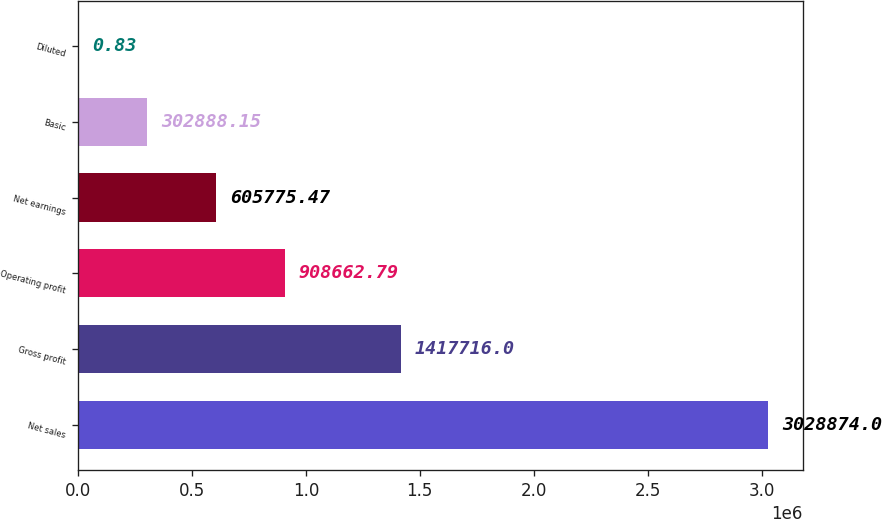Convert chart to OTSL. <chart><loc_0><loc_0><loc_500><loc_500><bar_chart><fcel>Net sales<fcel>Gross profit<fcel>Operating profit<fcel>Net earnings<fcel>Basic<fcel>Diluted<nl><fcel>3.02887e+06<fcel>1.41772e+06<fcel>908663<fcel>605775<fcel>302888<fcel>0.83<nl></chart> 